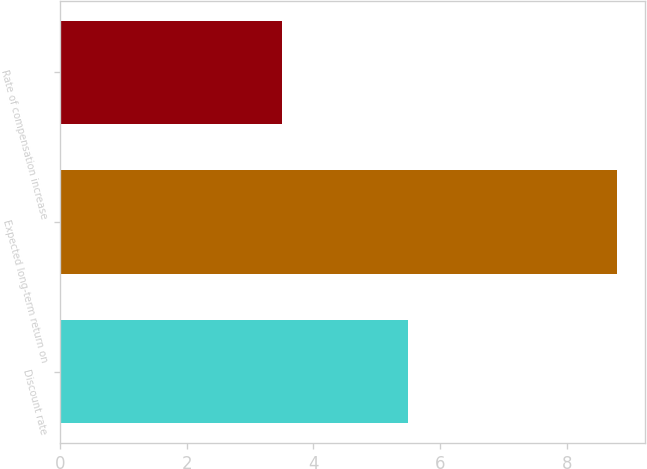<chart> <loc_0><loc_0><loc_500><loc_500><bar_chart><fcel>Discount rate<fcel>Expected long-term return on<fcel>Rate of compensation increase<nl><fcel>5.5<fcel>8.8<fcel>3.5<nl></chart> 